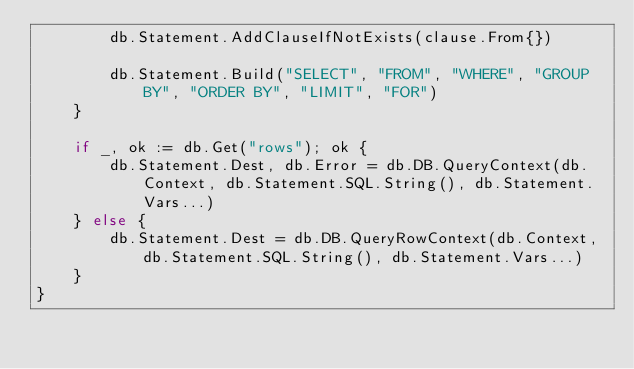<code> <loc_0><loc_0><loc_500><loc_500><_Go_>		db.Statement.AddClauseIfNotExists(clause.From{})

		db.Statement.Build("SELECT", "FROM", "WHERE", "GROUP BY", "ORDER BY", "LIMIT", "FOR")
	}

	if _, ok := db.Get("rows"); ok {
		db.Statement.Dest, db.Error = db.DB.QueryContext(db.Context, db.Statement.SQL.String(), db.Statement.Vars...)
	} else {
		db.Statement.Dest = db.DB.QueryRowContext(db.Context, db.Statement.SQL.String(), db.Statement.Vars...)
	}
}
</code> 